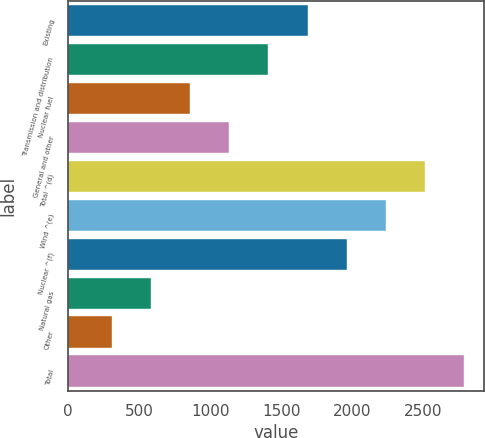Convert chart. <chart><loc_0><loc_0><loc_500><loc_500><bar_chart><fcel>Existing<fcel>Transmission and distribution<fcel>Nuclear fuel<fcel>General and other<fcel>Total ^(d)<fcel>Wind ^(e)<fcel>Nuclear ^(f)<fcel>Natural gas<fcel>Other<fcel>Total<nl><fcel>1686<fcel>1410<fcel>858<fcel>1134<fcel>2514<fcel>2238<fcel>1962<fcel>582<fcel>306<fcel>2790<nl></chart> 